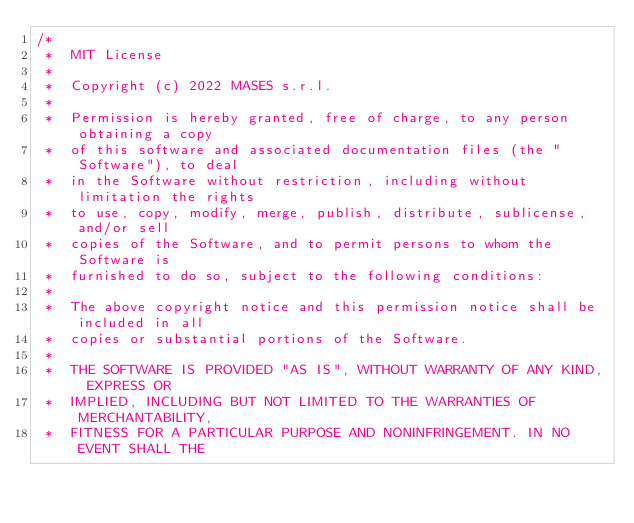Convert code to text. <code><loc_0><loc_0><loc_500><loc_500><_Java_>/*
 *  MIT License
 *
 *  Copyright (c) 2022 MASES s.r.l.
 *
 *  Permission is hereby granted, free of charge, to any person obtaining a copy
 *  of this software and associated documentation files (the "Software"), to deal
 *  in the Software without restriction, including without limitation the rights
 *  to use, copy, modify, merge, publish, distribute, sublicense, and/or sell
 *  copies of the Software, and to permit persons to whom the Software is
 *  furnished to do so, subject to the following conditions:
 *
 *  The above copyright notice and this permission notice shall be included in all
 *  copies or substantial portions of the Software.
 *
 *  THE SOFTWARE IS PROVIDED "AS IS", WITHOUT WARRANTY OF ANY KIND, EXPRESS OR
 *  IMPLIED, INCLUDING BUT NOT LIMITED TO THE WARRANTIES OF MERCHANTABILITY,
 *  FITNESS FOR A PARTICULAR PURPOSE AND NONINFRINGEMENT. IN NO EVENT SHALL THE</code> 